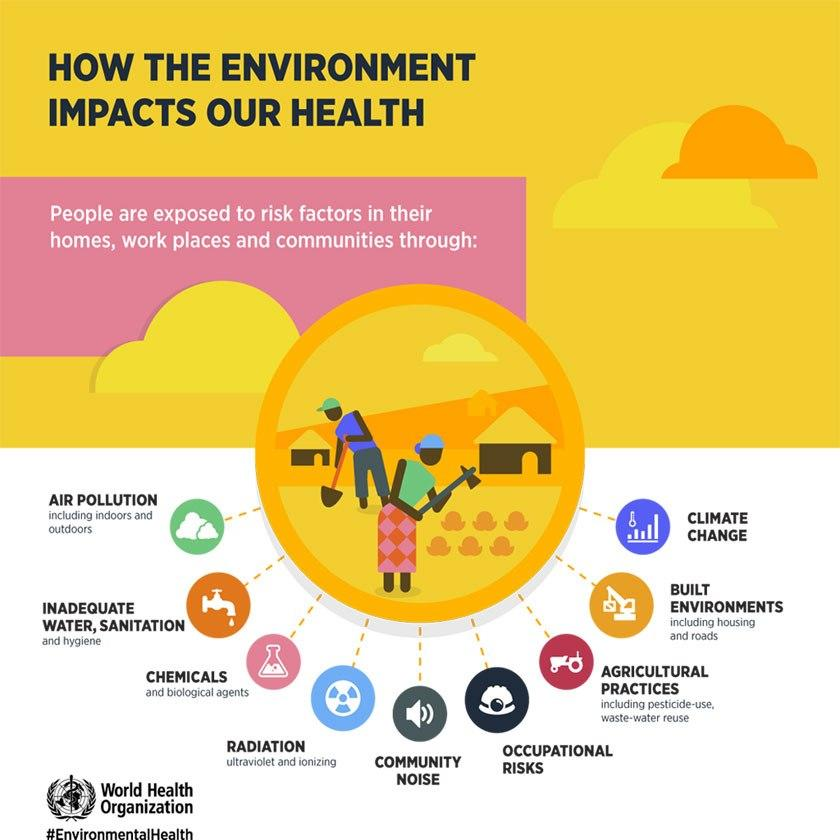Draw attention to some important aspects in this diagram. The symbol of the speaker represents community noise. There are two people represented in the vector. The second last factor in the list is "built environments. The color of the main title is black. 